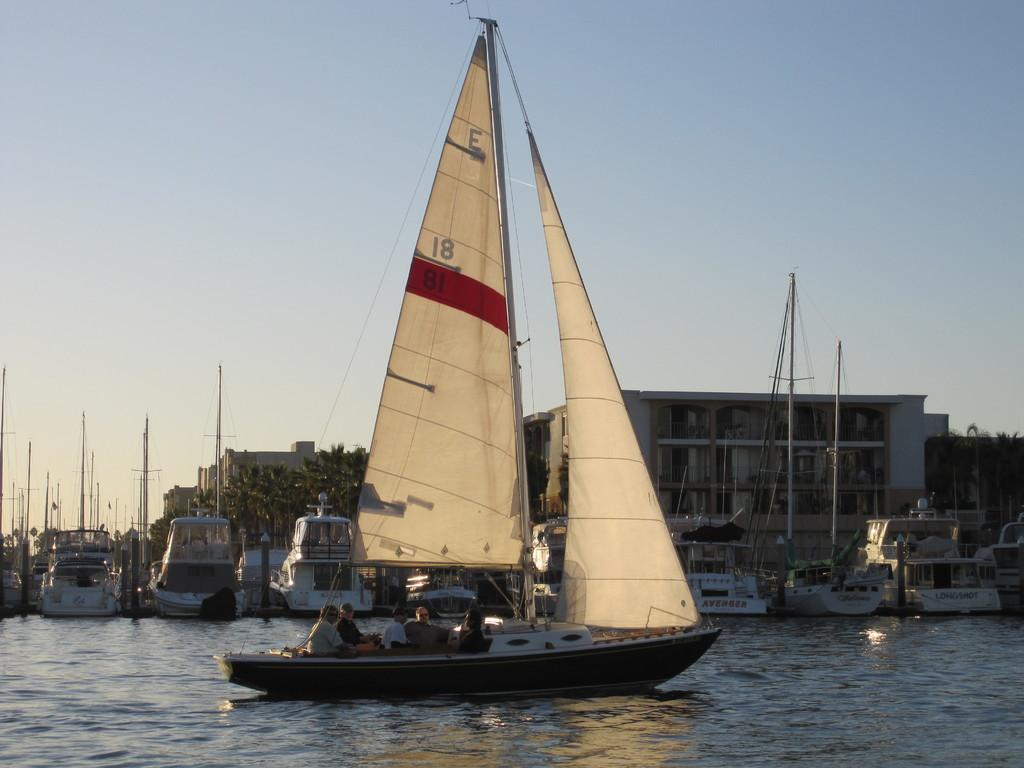What is the main subject of the image? The main subject of the image is ships. Where are the ships located in the image? The ships are on the water. What can be seen in the background of the image? There are buildings and trees in the background of the image. How would you describe the color of the sky in the image? The sky is blue and white in color. What type of finger can be seen in the image? There are no fingers present in the image; it features ships on the water with buildings and trees in the background. 